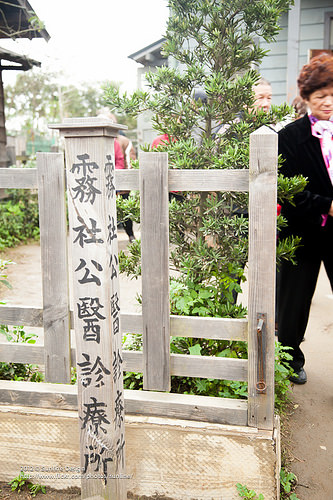<image>
Is the signpost on the fence? No. The signpost is not positioned on the fence. They may be near each other, but the signpost is not supported by or resting on top of the fence. Is the fence in front of the man? Yes. The fence is positioned in front of the man, appearing closer to the camera viewpoint. 